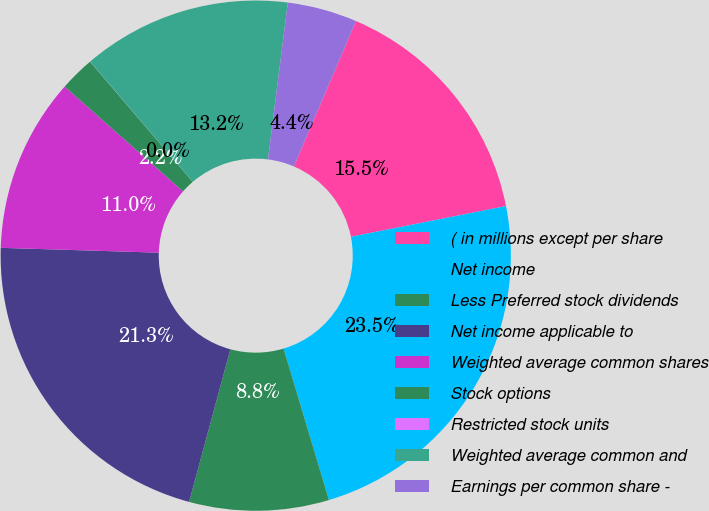Convert chart to OTSL. <chart><loc_0><loc_0><loc_500><loc_500><pie_chart><fcel>( in millions except per share<fcel>Net income<fcel>Less Preferred stock dividends<fcel>Net income applicable to<fcel>Weighted average common shares<fcel>Stock options<fcel>Restricted stock units<fcel>Weighted average common and<fcel>Earnings per common share -<nl><fcel>15.46%<fcel>23.48%<fcel>8.84%<fcel>21.28%<fcel>11.04%<fcel>2.22%<fcel>0.01%<fcel>13.25%<fcel>4.42%<nl></chart> 